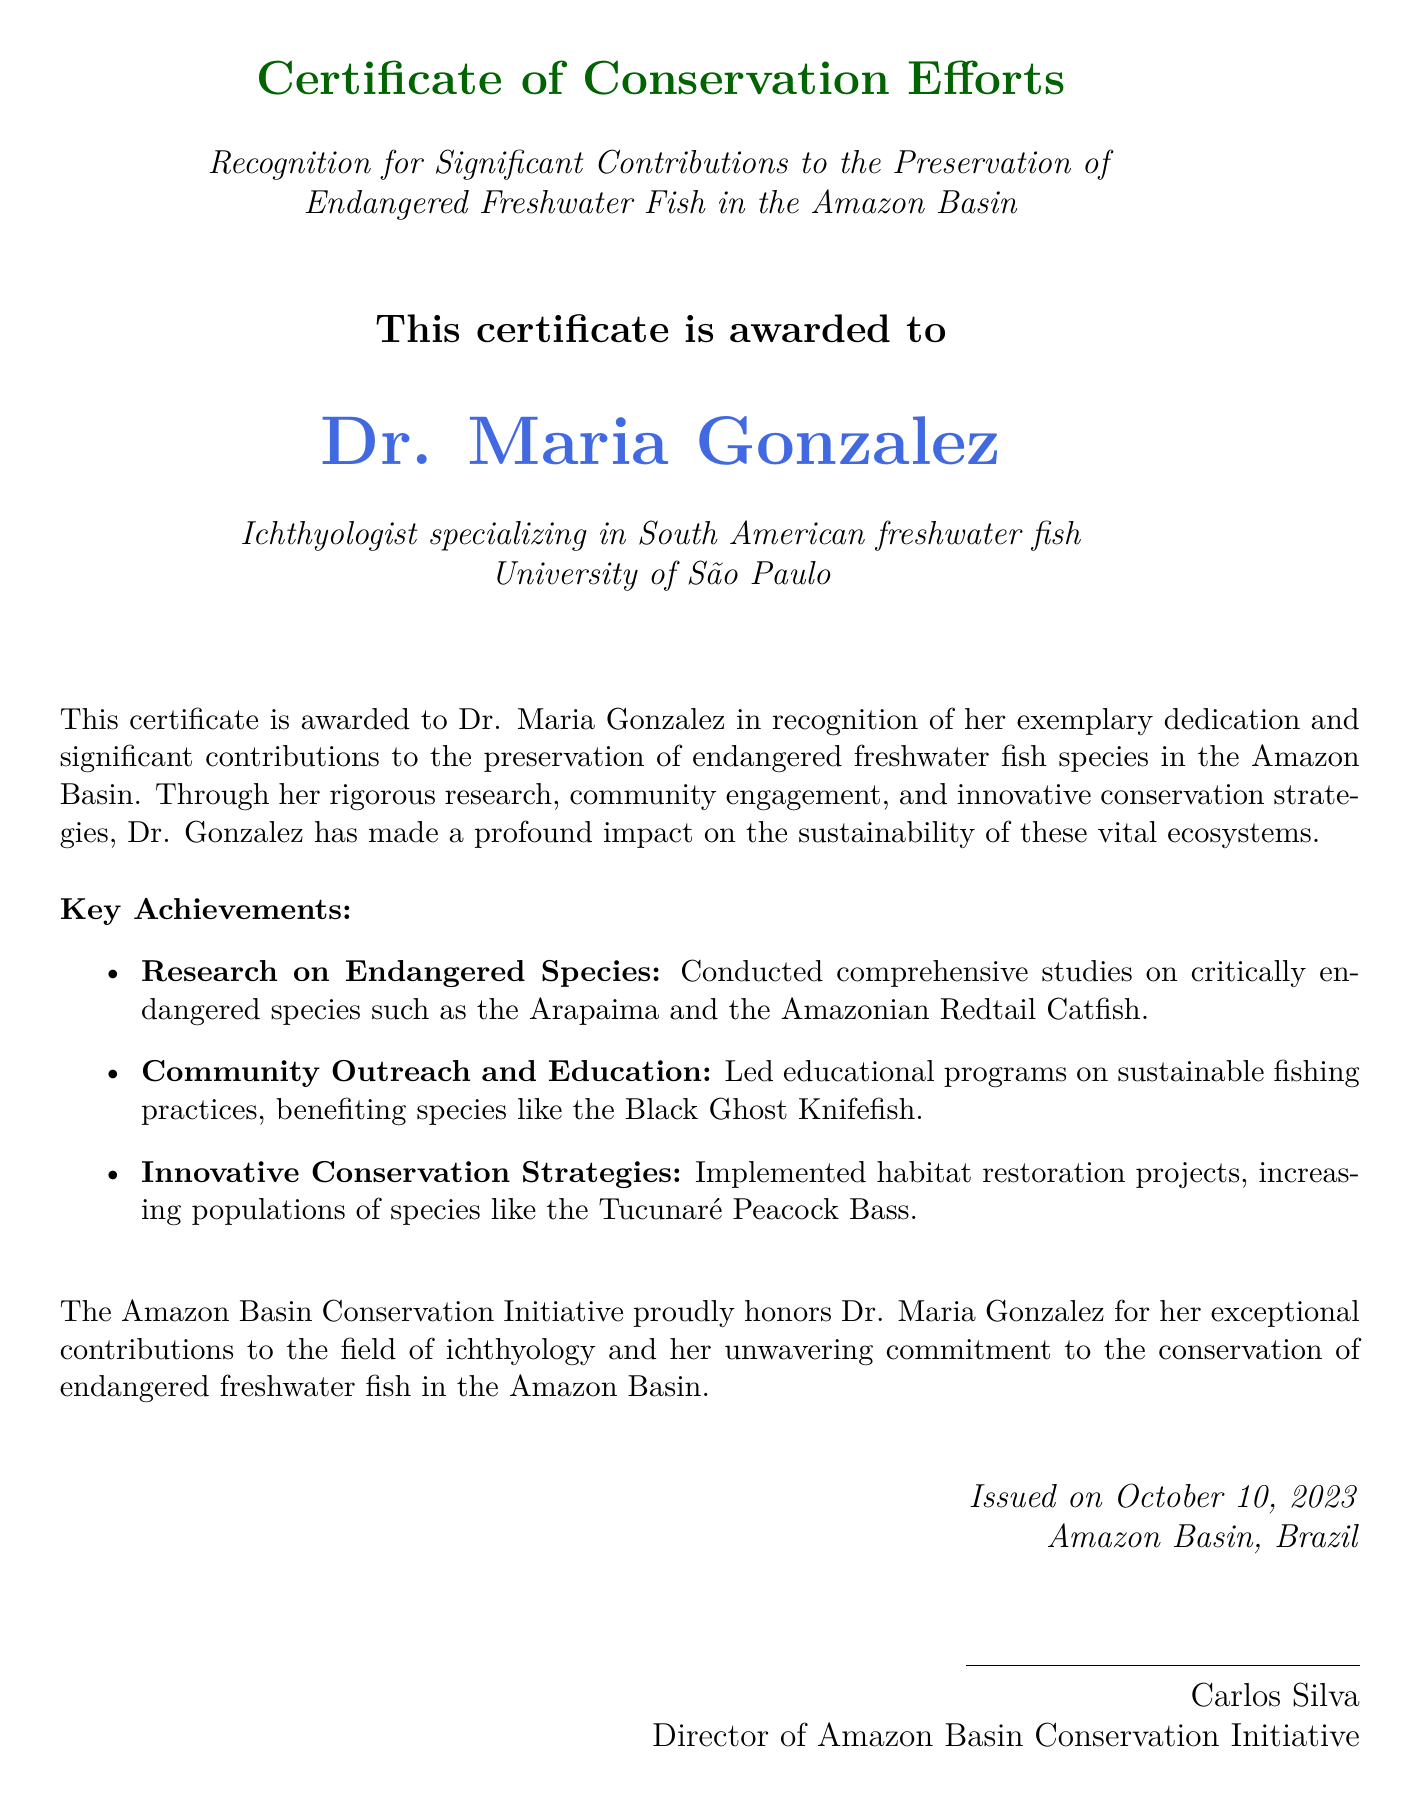What is the title of the certificate? The title is "Certificate of Conservation Efforts."
Answer: Certificate of Conservation Efforts Who is the recipient of this certificate? The certificate is awarded to Dr. Maria Gonzalez.
Answer: Dr. Maria Gonzalez What institution is Dr. Maria Gonzalez affiliated with? The document states her affiliation is "University of São Paulo."
Answer: University of São Paulo On what date was the certificate issued? The certificate was issued on "October 10, 2023."
Answer: October 10, 2023 What is one of the key achievements listed for Dr. Maria Gonzalez? The document mentions several key achievements, one being "Research on Endangered Species."
Answer: Research on Endangered Species What specific fish species is mentioned as critically endangered in the research? The document lists "Arapaima" as critically endangered.
Answer: Arapaima What is the role of Carlos Silva in relation to this document? Carlos Silva is identified as the "Director of Amazon Basin Conservation Initiative."
Answer: Director of Amazon Basin Conservation Initiative What type of initiatives did Dr. Gonzalez implement according to the certificate? The document states she implemented "habitat restoration projects."
Answer: habitat restoration projects What is the focus area of Dr. Maria Gonzalez's specialization? The document specifies that she specializes in "South American freshwater fish."
Answer: South American freshwater fish 